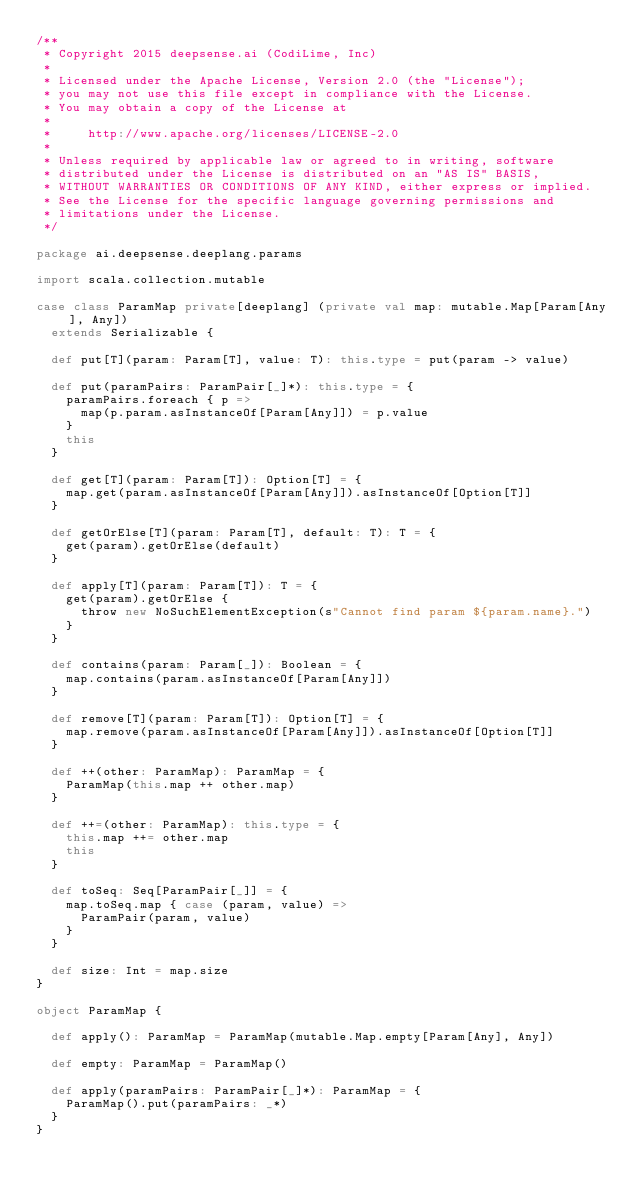<code> <loc_0><loc_0><loc_500><loc_500><_Scala_>/**
 * Copyright 2015 deepsense.ai (CodiLime, Inc)
 *
 * Licensed under the Apache License, Version 2.0 (the "License");
 * you may not use this file except in compliance with the License.
 * You may obtain a copy of the License at
 *
 *     http://www.apache.org/licenses/LICENSE-2.0
 *
 * Unless required by applicable law or agreed to in writing, software
 * distributed under the License is distributed on an "AS IS" BASIS,
 * WITHOUT WARRANTIES OR CONDITIONS OF ANY KIND, either express or implied.
 * See the License for the specific language governing permissions and
 * limitations under the License.
 */

package ai.deepsense.deeplang.params

import scala.collection.mutable

case class ParamMap private[deeplang] (private val map: mutable.Map[Param[Any], Any])
  extends Serializable {

  def put[T](param: Param[T], value: T): this.type = put(param -> value)

  def put(paramPairs: ParamPair[_]*): this.type = {
    paramPairs.foreach { p =>
      map(p.param.asInstanceOf[Param[Any]]) = p.value
    }
    this
  }

  def get[T](param: Param[T]): Option[T] = {
    map.get(param.asInstanceOf[Param[Any]]).asInstanceOf[Option[T]]
  }

  def getOrElse[T](param: Param[T], default: T): T = {
    get(param).getOrElse(default)
  }

  def apply[T](param: Param[T]): T = {
    get(param).getOrElse {
      throw new NoSuchElementException(s"Cannot find param ${param.name}.")
    }
  }

  def contains(param: Param[_]): Boolean = {
    map.contains(param.asInstanceOf[Param[Any]])
  }

  def remove[T](param: Param[T]): Option[T] = {
    map.remove(param.asInstanceOf[Param[Any]]).asInstanceOf[Option[T]]
  }

  def ++(other: ParamMap): ParamMap = {
    ParamMap(this.map ++ other.map)
  }

  def ++=(other: ParamMap): this.type = {
    this.map ++= other.map
    this
  }

  def toSeq: Seq[ParamPair[_]] = {
    map.toSeq.map { case (param, value) =>
      ParamPair(param, value)
    }
  }

  def size: Int = map.size
}

object ParamMap {

  def apply(): ParamMap = ParamMap(mutable.Map.empty[Param[Any], Any])

  def empty: ParamMap = ParamMap()

  def apply(paramPairs: ParamPair[_]*): ParamMap = {
    ParamMap().put(paramPairs: _*)
  }
}
</code> 